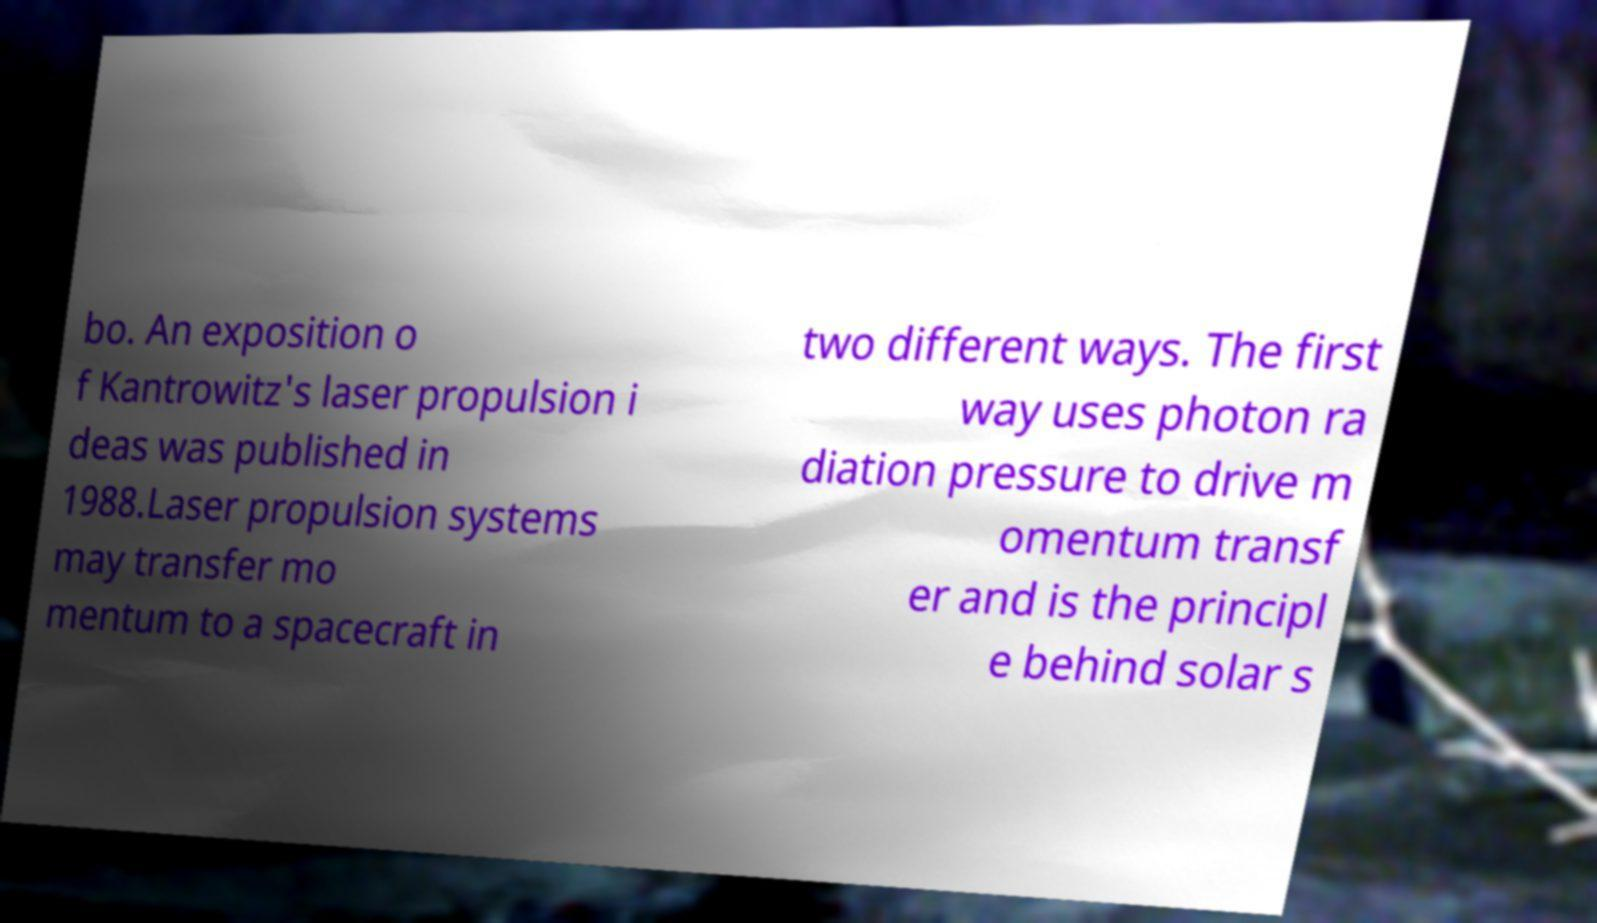I need the written content from this picture converted into text. Can you do that? bo. An exposition o f Kantrowitz's laser propulsion i deas was published in 1988.Laser propulsion systems may transfer mo mentum to a spacecraft in two different ways. The first way uses photon ra diation pressure to drive m omentum transf er and is the principl e behind solar s 